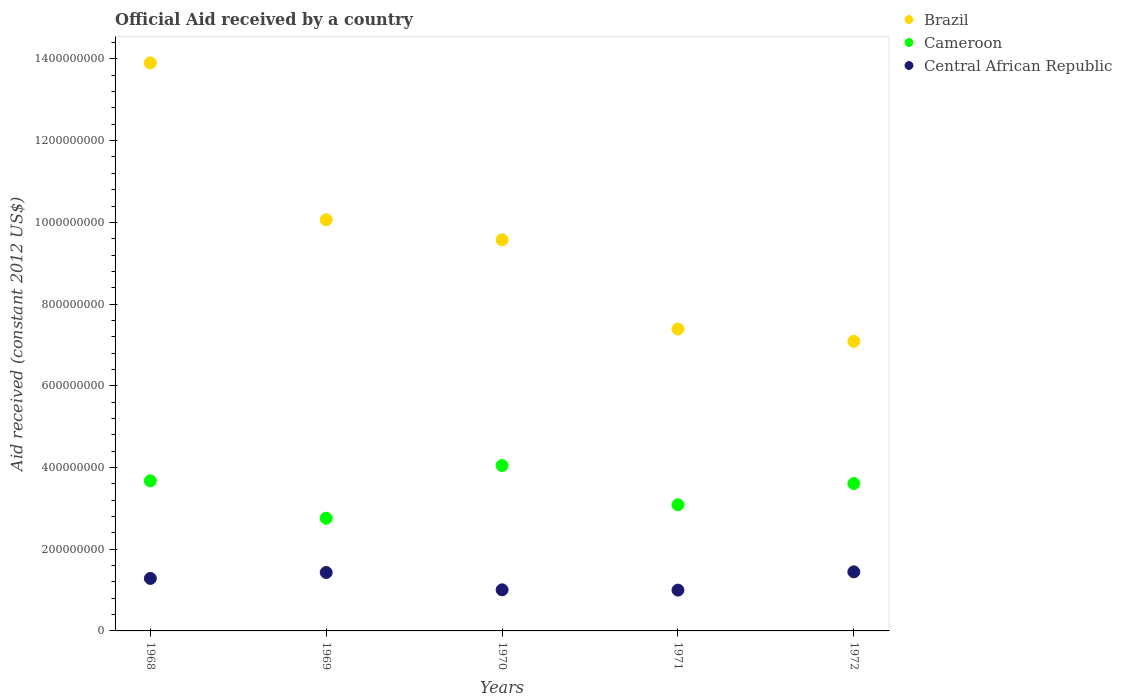How many different coloured dotlines are there?
Offer a terse response. 3. What is the net official aid received in Brazil in 1971?
Your response must be concise. 7.39e+08. Across all years, what is the maximum net official aid received in Cameroon?
Offer a terse response. 4.05e+08. Across all years, what is the minimum net official aid received in Cameroon?
Your answer should be very brief. 2.76e+08. In which year was the net official aid received in Cameroon minimum?
Give a very brief answer. 1969. What is the total net official aid received in Brazil in the graph?
Offer a terse response. 4.80e+09. What is the difference between the net official aid received in Cameroon in 1969 and that in 1970?
Provide a short and direct response. -1.29e+08. What is the difference between the net official aid received in Central African Republic in 1969 and the net official aid received in Brazil in 1968?
Offer a terse response. -1.25e+09. What is the average net official aid received in Brazil per year?
Your answer should be very brief. 9.60e+08. In the year 1969, what is the difference between the net official aid received in Cameroon and net official aid received in Brazil?
Keep it short and to the point. -7.31e+08. In how many years, is the net official aid received in Cameroon greater than 520000000 US$?
Provide a succinct answer. 0. What is the ratio of the net official aid received in Central African Republic in 1969 to that in 1972?
Make the answer very short. 0.99. Is the difference between the net official aid received in Cameroon in 1969 and 1970 greater than the difference between the net official aid received in Brazil in 1969 and 1970?
Make the answer very short. No. What is the difference between the highest and the second highest net official aid received in Cameroon?
Ensure brevity in your answer.  3.75e+07. What is the difference between the highest and the lowest net official aid received in Cameroon?
Keep it short and to the point. 1.29e+08. In how many years, is the net official aid received in Central African Republic greater than the average net official aid received in Central African Republic taken over all years?
Ensure brevity in your answer.  3. Is the sum of the net official aid received in Central African Republic in 1970 and 1971 greater than the maximum net official aid received in Cameroon across all years?
Your answer should be very brief. No. Is it the case that in every year, the sum of the net official aid received in Cameroon and net official aid received in Central African Republic  is greater than the net official aid received in Brazil?
Your answer should be very brief. No. Does the net official aid received in Central African Republic monotonically increase over the years?
Provide a succinct answer. No. Is the net official aid received in Cameroon strictly greater than the net official aid received in Central African Republic over the years?
Offer a very short reply. Yes. Is the net official aid received in Central African Republic strictly less than the net official aid received in Brazil over the years?
Provide a succinct answer. Yes. What is the difference between two consecutive major ticks on the Y-axis?
Ensure brevity in your answer.  2.00e+08. Does the graph contain any zero values?
Your answer should be compact. No. Does the graph contain grids?
Your answer should be very brief. No. How many legend labels are there?
Your response must be concise. 3. What is the title of the graph?
Your answer should be compact. Official Aid received by a country. Does "Brunei Darussalam" appear as one of the legend labels in the graph?
Provide a succinct answer. No. What is the label or title of the X-axis?
Ensure brevity in your answer.  Years. What is the label or title of the Y-axis?
Your answer should be very brief. Aid received (constant 2012 US$). What is the Aid received (constant 2012 US$) of Brazil in 1968?
Your answer should be very brief. 1.39e+09. What is the Aid received (constant 2012 US$) of Cameroon in 1968?
Your answer should be very brief. 3.67e+08. What is the Aid received (constant 2012 US$) in Central African Republic in 1968?
Your answer should be compact. 1.28e+08. What is the Aid received (constant 2012 US$) in Brazil in 1969?
Keep it short and to the point. 1.01e+09. What is the Aid received (constant 2012 US$) in Cameroon in 1969?
Ensure brevity in your answer.  2.76e+08. What is the Aid received (constant 2012 US$) in Central African Republic in 1969?
Your response must be concise. 1.43e+08. What is the Aid received (constant 2012 US$) of Brazil in 1970?
Your answer should be very brief. 9.57e+08. What is the Aid received (constant 2012 US$) of Cameroon in 1970?
Provide a succinct answer. 4.05e+08. What is the Aid received (constant 2012 US$) in Central African Republic in 1970?
Ensure brevity in your answer.  1.01e+08. What is the Aid received (constant 2012 US$) of Brazil in 1971?
Offer a very short reply. 7.39e+08. What is the Aid received (constant 2012 US$) in Cameroon in 1971?
Make the answer very short. 3.09e+08. What is the Aid received (constant 2012 US$) of Central African Republic in 1971?
Provide a succinct answer. 9.99e+07. What is the Aid received (constant 2012 US$) of Brazil in 1972?
Your answer should be very brief. 7.09e+08. What is the Aid received (constant 2012 US$) of Cameroon in 1972?
Keep it short and to the point. 3.61e+08. What is the Aid received (constant 2012 US$) of Central African Republic in 1972?
Your answer should be compact. 1.45e+08. Across all years, what is the maximum Aid received (constant 2012 US$) of Brazil?
Provide a short and direct response. 1.39e+09. Across all years, what is the maximum Aid received (constant 2012 US$) in Cameroon?
Provide a succinct answer. 4.05e+08. Across all years, what is the maximum Aid received (constant 2012 US$) of Central African Republic?
Your answer should be compact. 1.45e+08. Across all years, what is the minimum Aid received (constant 2012 US$) of Brazil?
Keep it short and to the point. 7.09e+08. Across all years, what is the minimum Aid received (constant 2012 US$) of Cameroon?
Keep it short and to the point. 2.76e+08. Across all years, what is the minimum Aid received (constant 2012 US$) in Central African Republic?
Your response must be concise. 9.99e+07. What is the total Aid received (constant 2012 US$) of Brazil in the graph?
Ensure brevity in your answer.  4.80e+09. What is the total Aid received (constant 2012 US$) in Cameroon in the graph?
Your response must be concise. 1.72e+09. What is the total Aid received (constant 2012 US$) of Central African Republic in the graph?
Your response must be concise. 6.17e+08. What is the difference between the Aid received (constant 2012 US$) in Brazil in 1968 and that in 1969?
Your answer should be compact. 3.84e+08. What is the difference between the Aid received (constant 2012 US$) in Cameroon in 1968 and that in 1969?
Keep it short and to the point. 9.15e+07. What is the difference between the Aid received (constant 2012 US$) in Central African Republic in 1968 and that in 1969?
Make the answer very short. -1.45e+07. What is the difference between the Aid received (constant 2012 US$) of Brazil in 1968 and that in 1970?
Your answer should be very brief. 4.33e+08. What is the difference between the Aid received (constant 2012 US$) in Cameroon in 1968 and that in 1970?
Offer a terse response. -3.75e+07. What is the difference between the Aid received (constant 2012 US$) of Central African Republic in 1968 and that in 1970?
Provide a short and direct response. 2.79e+07. What is the difference between the Aid received (constant 2012 US$) in Brazil in 1968 and that in 1971?
Provide a short and direct response. 6.51e+08. What is the difference between the Aid received (constant 2012 US$) in Cameroon in 1968 and that in 1971?
Offer a terse response. 5.85e+07. What is the difference between the Aid received (constant 2012 US$) of Central African Republic in 1968 and that in 1971?
Offer a very short reply. 2.86e+07. What is the difference between the Aid received (constant 2012 US$) of Brazil in 1968 and that in 1972?
Provide a succinct answer. 6.81e+08. What is the difference between the Aid received (constant 2012 US$) of Cameroon in 1968 and that in 1972?
Provide a short and direct response. 6.52e+06. What is the difference between the Aid received (constant 2012 US$) in Central African Republic in 1968 and that in 1972?
Provide a succinct answer. -1.61e+07. What is the difference between the Aid received (constant 2012 US$) in Brazil in 1969 and that in 1970?
Make the answer very short. 4.91e+07. What is the difference between the Aid received (constant 2012 US$) in Cameroon in 1969 and that in 1970?
Your answer should be compact. -1.29e+08. What is the difference between the Aid received (constant 2012 US$) in Central African Republic in 1969 and that in 1970?
Ensure brevity in your answer.  4.24e+07. What is the difference between the Aid received (constant 2012 US$) of Brazil in 1969 and that in 1971?
Ensure brevity in your answer.  2.67e+08. What is the difference between the Aid received (constant 2012 US$) of Cameroon in 1969 and that in 1971?
Offer a very short reply. -3.30e+07. What is the difference between the Aid received (constant 2012 US$) in Central African Republic in 1969 and that in 1971?
Your answer should be very brief. 4.31e+07. What is the difference between the Aid received (constant 2012 US$) of Brazil in 1969 and that in 1972?
Provide a succinct answer. 2.98e+08. What is the difference between the Aid received (constant 2012 US$) in Cameroon in 1969 and that in 1972?
Your answer should be very brief. -8.50e+07. What is the difference between the Aid received (constant 2012 US$) of Central African Republic in 1969 and that in 1972?
Offer a terse response. -1.59e+06. What is the difference between the Aid received (constant 2012 US$) in Brazil in 1970 and that in 1971?
Provide a succinct answer. 2.18e+08. What is the difference between the Aid received (constant 2012 US$) in Cameroon in 1970 and that in 1971?
Your response must be concise. 9.60e+07. What is the difference between the Aid received (constant 2012 US$) in Central African Republic in 1970 and that in 1971?
Give a very brief answer. 7.10e+05. What is the difference between the Aid received (constant 2012 US$) in Brazil in 1970 and that in 1972?
Make the answer very short. 2.48e+08. What is the difference between the Aid received (constant 2012 US$) in Cameroon in 1970 and that in 1972?
Your response must be concise. 4.40e+07. What is the difference between the Aid received (constant 2012 US$) in Central African Republic in 1970 and that in 1972?
Keep it short and to the point. -4.40e+07. What is the difference between the Aid received (constant 2012 US$) of Brazil in 1971 and that in 1972?
Provide a short and direct response. 3.03e+07. What is the difference between the Aid received (constant 2012 US$) of Cameroon in 1971 and that in 1972?
Make the answer very short. -5.20e+07. What is the difference between the Aid received (constant 2012 US$) of Central African Republic in 1971 and that in 1972?
Make the answer very short. -4.47e+07. What is the difference between the Aid received (constant 2012 US$) in Brazil in 1968 and the Aid received (constant 2012 US$) in Cameroon in 1969?
Make the answer very short. 1.11e+09. What is the difference between the Aid received (constant 2012 US$) in Brazil in 1968 and the Aid received (constant 2012 US$) in Central African Republic in 1969?
Offer a very short reply. 1.25e+09. What is the difference between the Aid received (constant 2012 US$) in Cameroon in 1968 and the Aid received (constant 2012 US$) in Central African Republic in 1969?
Provide a succinct answer. 2.24e+08. What is the difference between the Aid received (constant 2012 US$) in Brazil in 1968 and the Aid received (constant 2012 US$) in Cameroon in 1970?
Ensure brevity in your answer.  9.85e+08. What is the difference between the Aid received (constant 2012 US$) in Brazil in 1968 and the Aid received (constant 2012 US$) in Central African Republic in 1970?
Your response must be concise. 1.29e+09. What is the difference between the Aid received (constant 2012 US$) in Cameroon in 1968 and the Aid received (constant 2012 US$) in Central African Republic in 1970?
Offer a terse response. 2.67e+08. What is the difference between the Aid received (constant 2012 US$) of Brazil in 1968 and the Aid received (constant 2012 US$) of Cameroon in 1971?
Offer a very short reply. 1.08e+09. What is the difference between the Aid received (constant 2012 US$) of Brazil in 1968 and the Aid received (constant 2012 US$) of Central African Republic in 1971?
Your answer should be very brief. 1.29e+09. What is the difference between the Aid received (constant 2012 US$) of Cameroon in 1968 and the Aid received (constant 2012 US$) of Central African Republic in 1971?
Make the answer very short. 2.67e+08. What is the difference between the Aid received (constant 2012 US$) of Brazil in 1968 and the Aid received (constant 2012 US$) of Cameroon in 1972?
Offer a terse response. 1.03e+09. What is the difference between the Aid received (constant 2012 US$) in Brazil in 1968 and the Aid received (constant 2012 US$) in Central African Republic in 1972?
Offer a terse response. 1.25e+09. What is the difference between the Aid received (constant 2012 US$) in Cameroon in 1968 and the Aid received (constant 2012 US$) in Central African Republic in 1972?
Provide a succinct answer. 2.23e+08. What is the difference between the Aid received (constant 2012 US$) in Brazil in 1969 and the Aid received (constant 2012 US$) in Cameroon in 1970?
Make the answer very short. 6.02e+08. What is the difference between the Aid received (constant 2012 US$) in Brazil in 1969 and the Aid received (constant 2012 US$) in Central African Republic in 1970?
Your answer should be very brief. 9.06e+08. What is the difference between the Aid received (constant 2012 US$) in Cameroon in 1969 and the Aid received (constant 2012 US$) in Central African Republic in 1970?
Ensure brevity in your answer.  1.75e+08. What is the difference between the Aid received (constant 2012 US$) of Brazil in 1969 and the Aid received (constant 2012 US$) of Cameroon in 1971?
Provide a short and direct response. 6.98e+08. What is the difference between the Aid received (constant 2012 US$) in Brazil in 1969 and the Aid received (constant 2012 US$) in Central African Republic in 1971?
Make the answer very short. 9.07e+08. What is the difference between the Aid received (constant 2012 US$) in Cameroon in 1969 and the Aid received (constant 2012 US$) in Central African Republic in 1971?
Offer a very short reply. 1.76e+08. What is the difference between the Aid received (constant 2012 US$) of Brazil in 1969 and the Aid received (constant 2012 US$) of Cameroon in 1972?
Your answer should be compact. 6.46e+08. What is the difference between the Aid received (constant 2012 US$) in Brazil in 1969 and the Aid received (constant 2012 US$) in Central African Republic in 1972?
Provide a succinct answer. 8.62e+08. What is the difference between the Aid received (constant 2012 US$) in Cameroon in 1969 and the Aid received (constant 2012 US$) in Central African Republic in 1972?
Offer a terse response. 1.31e+08. What is the difference between the Aid received (constant 2012 US$) in Brazil in 1970 and the Aid received (constant 2012 US$) in Cameroon in 1971?
Give a very brief answer. 6.48e+08. What is the difference between the Aid received (constant 2012 US$) in Brazil in 1970 and the Aid received (constant 2012 US$) in Central African Republic in 1971?
Give a very brief answer. 8.57e+08. What is the difference between the Aid received (constant 2012 US$) of Cameroon in 1970 and the Aid received (constant 2012 US$) of Central African Republic in 1971?
Ensure brevity in your answer.  3.05e+08. What is the difference between the Aid received (constant 2012 US$) in Brazil in 1970 and the Aid received (constant 2012 US$) in Cameroon in 1972?
Offer a very short reply. 5.96e+08. What is the difference between the Aid received (constant 2012 US$) of Brazil in 1970 and the Aid received (constant 2012 US$) of Central African Republic in 1972?
Ensure brevity in your answer.  8.13e+08. What is the difference between the Aid received (constant 2012 US$) in Cameroon in 1970 and the Aid received (constant 2012 US$) in Central African Republic in 1972?
Your response must be concise. 2.60e+08. What is the difference between the Aid received (constant 2012 US$) of Brazil in 1971 and the Aid received (constant 2012 US$) of Cameroon in 1972?
Give a very brief answer. 3.78e+08. What is the difference between the Aid received (constant 2012 US$) in Brazil in 1971 and the Aid received (constant 2012 US$) in Central African Republic in 1972?
Give a very brief answer. 5.94e+08. What is the difference between the Aid received (constant 2012 US$) in Cameroon in 1971 and the Aid received (constant 2012 US$) in Central African Republic in 1972?
Give a very brief answer. 1.64e+08. What is the average Aid received (constant 2012 US$) of Brazil per year?
Ensure brevity in your answer.  9.60e+08. What is the average Aid received (constant 2012 US$) in Cameroon per year?
Provide a short and direct response. 3.44e+08. What is the average Aid received (constant 2012 US$) in Central African Republic per year?
Your answer should be compact. 1.23e+08. In the year 1968, what is the difference between the Aid received (constant 2012 US$) in Brazil and Aid received (constant 2012 US$) in Cameroon?
Your response must be concise. 1.02e+09. In the year 1968, what is the difference between the Aid received (constant 2012 US$) of Brazil and Aid received (constant 2012 US$) of Central African Republic?
Give a very brief answer. 1.26e+09. In the year 1968, what is the difference between the Aid received (constant 2012 US$) of Cameroon and Aid received (constant 2012 US$) of Central African Republic?
Provide a short and direct response. 2.39e+08. In the year 1969, what is the difference between the Aid received (constant 2012 US$) in Brazil and Aid received (constant 2012 US$) in Cameroon?
Keep it short and to the point. 7.31e+08. In the year 1969, what is the difference between the Aid received (constant 2012 US$) in Brazil and Aid received (constant 2012 US$) in Central African Republic?
Offer a very short reply. 8.63e+08. In the year 1969, what is the difference between the Aid received (constant 2012 US$) in Cameroon and Aid received (constant 2012 US$) in Central African Republic?
Provide a short and direct response. 1.33e+08. In the year 1970, what is the difference between the Aid received (constant 2012 US$) in Brazil and Aid received (constant 2012 US$) in Cameroon?
Make the answer very short. 5.52e+08. In the year 1970, what is the difference between the Aid received (constant 2012 US$) of Brazil and Aid received (constant 2012 US$) of Central African Republic?
Keep it short and to the point. 8.57e+08. In the year 1970, what is the difference between the Aid received (constant 2012 US$) in Cameroon and Aid received (constant 2012 US$) in Central African Republic?
Your answer should be very brief. 3.04e+08. In the year 1971, what is the difference between the Aid received (constant 2012 US$) of Brazil and Aid received (constant 2012 US$) of Cameroon?
Keep it short and to the point. 4.30e+08. In the year 1971, what is the difference between the Aid received (constant 2012 US$) in Brazil and Aid received (constant 2012 US$) in Central African Republic?
Provide a short and direct response. 6.39e+08. In the year 1971, what is the difference between the Aid received (constant 2012 US$) in Cameroon and Aid received (constant 2012 US$) in Central African Republic?
Give a very brief answer. 2.09e+08. In the year 1972, what is the difference between the Aid received (constant 2012 US$) of Brazil and Aid received (constant 2012 US$) of Cameroon?
Offer a very short reply. 3.48e+08. In the year 1972, what is the difference between the Aid received (constant 2012 US$) of Brazil and Aid received (constant 2012 US$) of Central African Republic?
Keep it short and to the point. 5.64e+08. In the year 1972, what is the difference between the Aid received (constant 2012 US$) of Cameroon and Aid received (constant 2012 US$) of Central African Republic?
Your response must be concise. 2.16e+08. What is the ratio of the Aid received (constant 2012 US$) of Brazil in 1968 to that in 1969?
Your response must be concise. 1.38. What is the ratio of the Aid received (constant 2012 US$) in Cameroon in 1968 to that in 1969?
Your response must be concise. 1.33. What is the ratio of the Aid received (constant 2012 US$) in Central African Republic in 1968 to that in 1969?
Your answer should be very brief. 0.9. What is the ratio of the Aid received (constant 2012 US$) of Brazil in 1968 to that in 1970?
Make the answer very short. 1.45. What is the ratio of the Aid received (constant 2012 US$) in Cameroon in 1968 to that in 1970?
Provide a succinct answer. 0.91. What is the ratio of the Aid received (constant 2012 US$) of Central African Republic in 1968 to that in 1970?
Your response must be concise. 1.28. What is the ratio of the Aid received (constant 2012 US$) of Brazil in 1968 to that in 1971?
Make the answer very short. 1.88. What is the ratio of the Aid received (constant 2012 US$) of Cameroon in 1968 to that in 1971?
Provide a short and direct response. 1.19. What is the ratio of the Aid received (constant 2012 US$) in Central African Republic in 1968 to that in 1971?
Your answer should be very brief. 1.29. What is the ratio of the Aid received (constant 2012 US$) in Brazil in 1968 to that in 1972?
Your answer should be very brief. 1.96. What is the ratio of the Aid received (constant 2012 US$) of Cameroon in 1968 to that in 1972?
Provide a short and direct response. 1.02. What is the ratio of the Aid received (constant 2012 US$) in Central African Republic in 1968 to that in 1972?
Ensure brevity in your answer.  0.89. What is the ratio of the Aid received (constant 2012 US$) of Brazil in 1969 to that in 1970?
Your response must be concise. 1.05. What is the ratio of the Aid received (constant 2012 US$) of Cameroon in 1969 to that in 1970?
Offer a terse response. 0.68. What is the ratio of the Aid received (constant 2012 US$) of Central African Republic in 1969 to that in 1970?
Offer a terse response. 1.42. What is the ratio of the Aid received (constant 2012 US$) of Brazil in 1969 to that in 1971?
Provide a short and direct response. 1.36. What is the ratio of the Aid received (constant 2012 US$) in Cameroon in 1969 to that in 1971?
Keep it short and to the point. 0.89. What is the ratio of the Aid received (constant 2012 US$) of Central African Republic in 1969 to that in 1971?
Your answer should be very brief. 1.43. What is the ratio of the Aid received (constant 2012 US$) in Brazil in 1969 to that in 1972?
Your response must be concise. 1.42. What is the ratio of the Aid received (constant 2012 US$) in Cameroon in 1969 to that in 1972?
Provide a succinct answer. 0.76. What is the ratio of the Aid received (constant 2012 US$) of Brazil in 1970 to that in 1971?
Your answer should be compact. 1.3. What is the ratio of the Aid received (constant 2012 US$) of Cameroon in 1970 to that in 1971?
Keep it short and to the point. 1.31. What is the ratio of the Aid received (constant 2012 US$) of Central African Republic in 1970 to that in 1971?
Your response must be concise. 1.01. What is the ratio of the Aid received (constant 2012 US$) of Brazil in 1970 to that in 1972?
Provide a short and direct response. 1.35. What is the ratio of the Aid received (constant 2012 US$) in Cameroon in 1970 to that in 1972?
Keep it short and to the point. 1.12. What is the ratio of the Aid received (constant 2012 US$) of Central African Republic in 1970 to that in 1972?
Your answer should be compact. 0.7. What is the ratio of the Aid received (constant 2012 US$) of Brazil in 1971 to that in 1972?
Provide a short and direct response. 1.04. What is the ratio of the Aid received (constant 2012 US$) in Cameroon in 1971 to that in 1972?
Ensure brevity in your answer.  0.86. What is the ratio of the Aid received (constant 2012 US$) of Central African Republic in 1971 to that in 1972?
Ensure brevity in your answer.  0.69. What is the difference between the highest and the second highest Aid received (constant 2012 US$) in Brazil?
Your answer should be very brief. 3.84e+08. What is the difference between the highest and the second highest Aid received (constant 2012 US$) in Cameroon?
Your response must be concise. 3.75e+07. What is the difference between the highest and the second highest Aid received (constant 2012 US$) in Central African Republic?
Ensure brevity in your answer.  1.59e+06. What is the difference between the highest and the lowest Aid received (constant 2012 US$) of Brazil?
Your answer should be very brief. 6.81e+08. What is the difference between the highest and the lowest Aid received (constant 2012 US$) of Cameroon?
Keep it short and to the point. 1.29e+08. What is the difference between the highest and the lowest Aid received (constant 2012 US$) of Central African Republic?
Offer a terse response. 4.47e+07. 